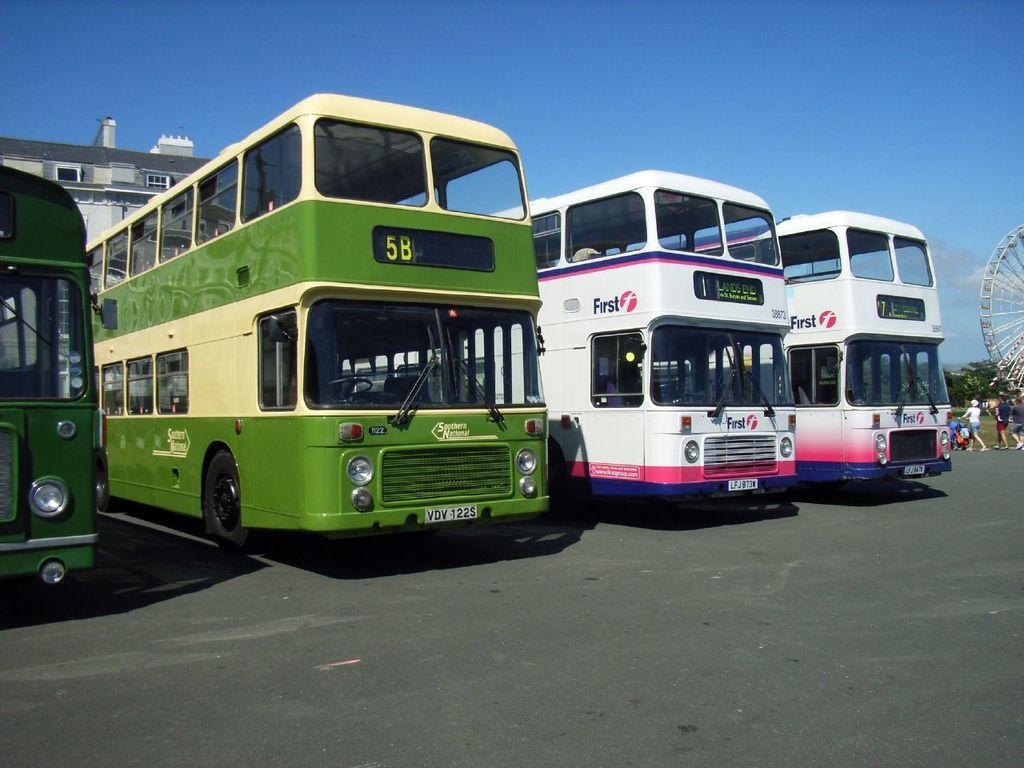What type of vehicles can be seen on the road in the image? There are buses on the road in the image. What else can be seen in the background of the image? There are people, trees, a giant wheel, buildings, and the sky visible in the background. What type of bells can be heard ringing in the image? There is no mention of bells or any sounds in the image, so it is not possible to determine if any bells are ringing. What type of care is being provided to the people in the image? There is no indication of any care being provided to the people in the image; they are simply visible in the background. 